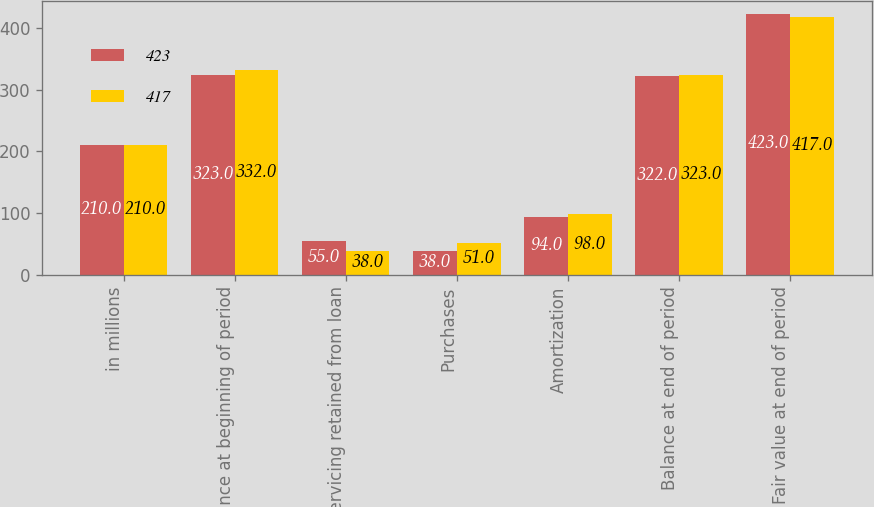Convert chart. <chart><loc_0><loc_0><loc_500><loc_500><stacked_bar_chart><ecel><fcel>in millions<fcel>Balance at beginning of period<fcel>Servicing retained from loan<fcel>Purchases<fcel>Amortization<fcel>Balance at end of period<fcel>Fair value at end of period<nl><fcel>423<fcel>210<fcel>323<fcel>55<fcel>38<fcel>94<fcel>322<fcel>423<nl><fcel>417<fcel>210<fcel>332<fcel>38<fcel>51<fcel>98<fcel>323<fcel>417<nl></chart> 